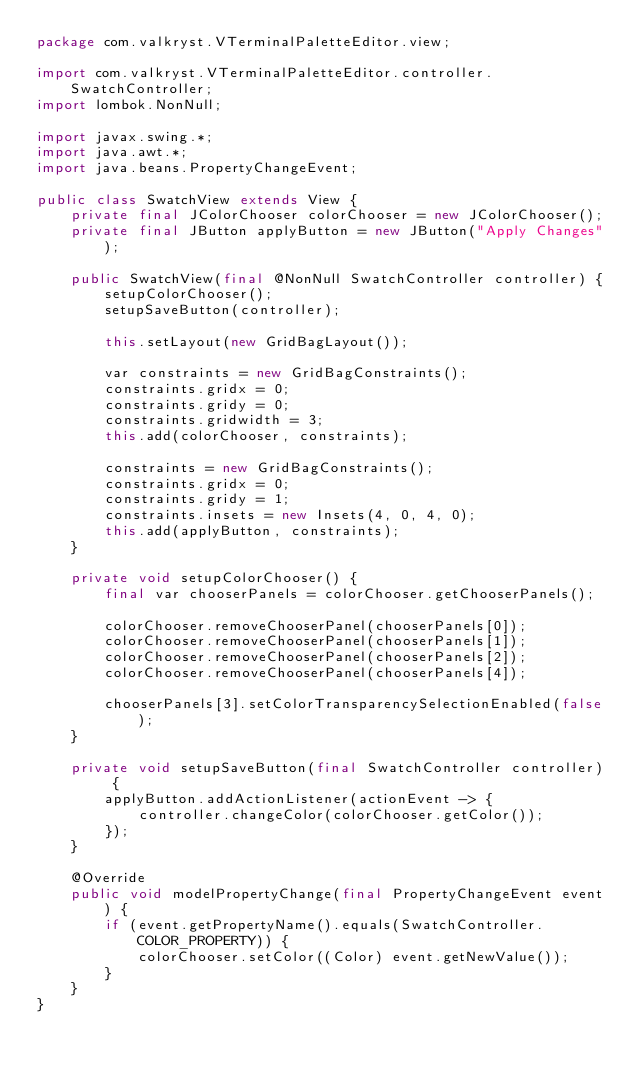Convert code to text. <code><loc_0><loc_0><loc_500><loc_500><_Java_>package com.valkryst.VTerminalPaletteEditor.view;

import com.valkryst.VTerminalPaletteEditor.controller.SwatchController;
import lombok.NonNull;

import javax.swing.*;
import java.awt.*;
import java.beans.PropertyChangeEvent;

public class SwatchView extends View {
	private final JColorChooser colorChooser = new JColorChooser();
	private final JButton applyButton = new JButton("Apply Changes");

	public SwatchView(final @NonNull SwatchController controller) {
		setupColorChooser();
		setupSaveButton(controller);

		this.setLayout(new GridBagLayout());

		var constraints = new GridBagConstraints();
		constraints.gridx = 0;
		constraints.gridy = 0;
		constraints.gridwidth = 3;
		this.add(colorChooser, constraints);

		constraints = new GridBagConstraints();
		constraints.gridx = 0;
		constraints.gridy = 1;
		constraints.insets = new Insets(4, 0, 4, 0);
		this.add(applyButton, constraints);
	}

	private void setupColorChooser() {
		final var chooserPanels = colorChooser.getChooserPanels();

		colorChooser.removeChooserPanel(chooserPanels[0]);
		colorChooser.removeChooserPanel(chooserPanels[1]);
		colorChooser.removeChooserPanel(chooserPanels[2]);
		colorChooser.removeChooserPanel(chooserPanels[4]);

		chooserPanels[3].setColorTransparencySelectionEnabled(false);
	}

	private void setupSaveButton(final SwatchController controller) {
		applyButton.addActionListener(actionEvent -> {
			controller.changeColor(colorChooser.getColor());
		});
	}

	@Override
	public void modelPropertyChange(final PropertyChangeEvent event) {
		if (event.getPropertyName().equals(SwatchController.COLOR_PROPERTY)) {
			colorChooser.setColor((Color) event.getNewValue());
		}
	}
}
</code> 